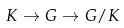<formula> <loc_0><loc_0><loc_500><loc_500>K \to G \to G / K</formula> 